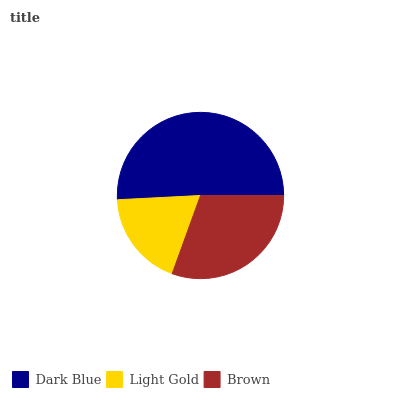Is Light Gold the minimum?
Answer yes or no. Yes. Is Dark Blue the maximum?
Answer yes or no. Yes. Is Brown the minimum?
Answer yes or no. No. Is Brown the maximum?
Answer yes or no. No. Is Brown greater than Light Gold?
Answer yes or no. Yes. Is Light Gold less than Brown?
Answer yes or no. Yes. Is Light Gold greater than Brown?
Answer yes or no. No. Is Brown less than Light Gold?
Answer yes or no. No. Is Brown the high median?
Answer yes or no. Yes. Is Brown the low median?
Answer yes or no. Yes. Is Dark Blue the high median?
Answer yes or no. No. Is Dark Blue the low median?
Answer yes or no. No. 